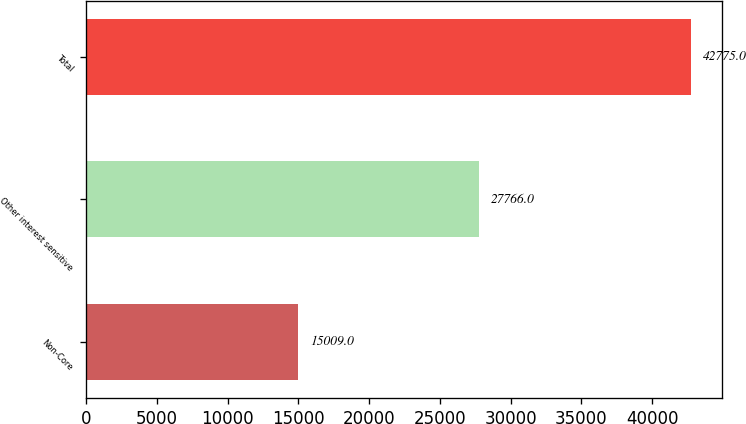Convert chart. <chart><loc_0><loc_0><loc_500><loc_500><bar_chart><fcel>Non-Core<fcel>Other interest sensitive<fcel>Total<nl><fcel>15009<fcel>27766<fcel>42775<nl></chart> 